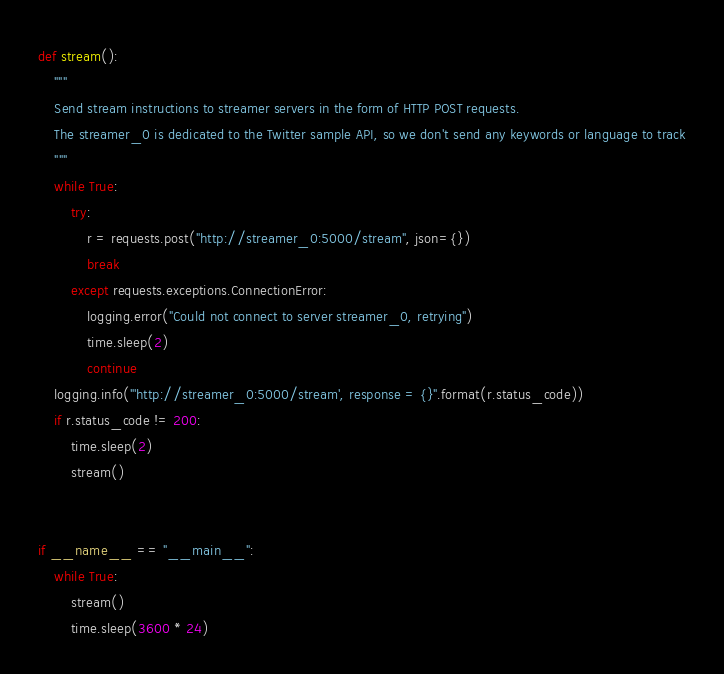Convert code to text. <code><loc_0><loc_0><loc_500><loc_500><_Python_>def stream():
    """
    Send stream instructions to streamer servers in the form of HTTP POST requests.
    The streamer_0 is dedicated to the Twitter sample API, so we don't send any keywords or language to track
    """
    while True:
        try:
            r = requests.post("http://streamer_0:5000/stream", json={})
            break
        except requests.exceptions.ConnectionError:
            logging.error("Could not connect to server streamer_0, retrying")
            time.sleep(2)
            continue
    logging.info("'http://streamer_0:5000/stream', response = {}".format(r.status_code))
    if r.status_code != 200:
        time.sleep(2)
        stream()


if __name__ == "__main__":
    while True:
        stream()
        time.sleep(3600 * 24)
</code> 